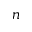Convert formula to latex. <formula><loc_0><loc_0><loc_500><loc_500>n</formula> 